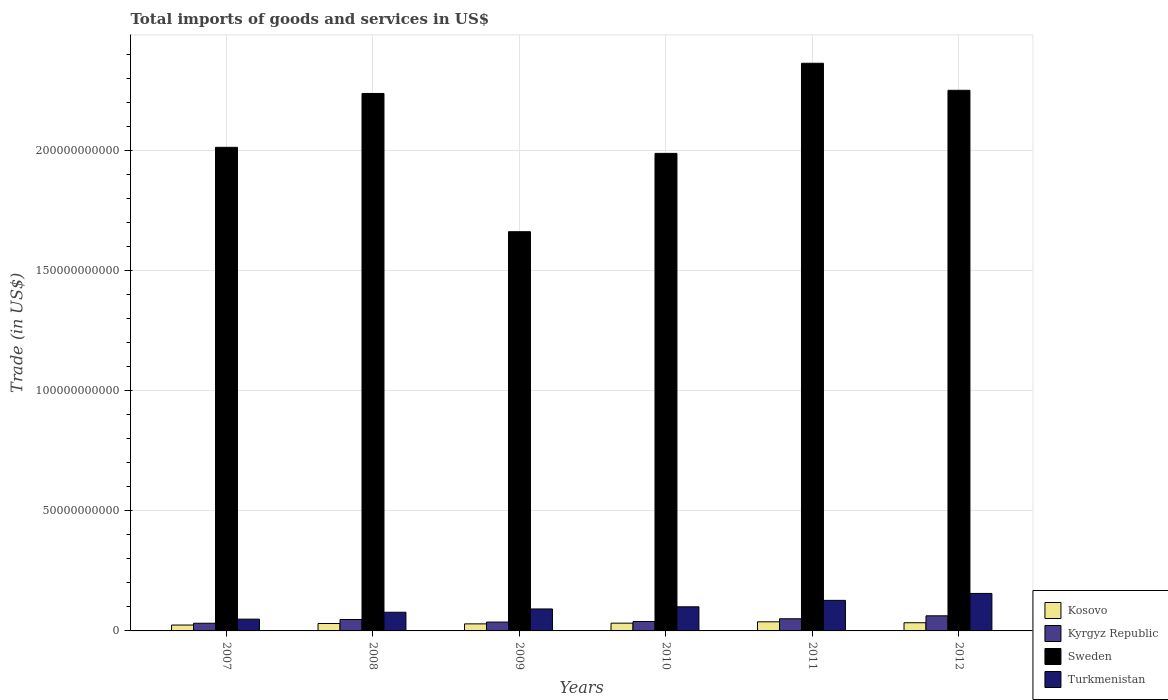How many different coloured bars are there?
Ensure brevity in your answer.  4. Are the number of bars per tick equal to the number of legend labels?
Offer a terse response. Yes. Are the number of bars on each tick of the X-axis equal?
Your response must be concise. Yes. How many bars are there on the 4th tick from the left?
Give a very brief answer. 4. How many bars are there on the 6th tick from the right?
Provide a short and direct response. 4. What is the label of the 6th group of bars from the left?
Your response must be concise. 2012. What is the total imports of goods and services in Kosovo in 2011?
Your answer should be compact. 3.80e+09. Across all years, what is the maximum total imports of goods and services in Sweden?
Make the answer very short. 2.36e+11. Across all years, what is the minimum total imports of goods and services in Kosovo?
Offer a terse response. 2.45e+09. In which year was the total imports of goods and services in Sweden minimum?
Give a very brief answer. 2009. What is the total total imports of goods and services in Sweden in the graph?
Your answer should be very brief. 1.25e+12. What is the difference between the total imports of goods and services in Kyrgyz Republic in 2010 and that in 2012?
Give a very brief answer. -2.38e+09. What is the difference between the total imports of goods and services in Kosovo in 2008 and the total imports of goods and services in Turkmenistan in 2010?
Give a very brief answer. -6.96e+09. What is the average total imports of goods and services in Sweden per year?
Your response must be concise. 2.09e+11. In the year 2012, what is the difference between the total imports of goods and services in Kosovo and total imports of goods and services in Kyrgyz Republic?
Make the answer very short. -2.89e+09. In how many years, is the total imports of goods and services in Turkmenistan greater than 140000000000 US$?
Make the answer very short. 0. What is the ratio of the total imports of goods and services in Kyrgyz Republic in 2007 to that in 2009?
Give a very brief answer. 0.87. Is the total imports of goods and services in Kyrgyz Republic in 2008 less than that in 2009?
Offer a very short reply. No. Is the difference between the total imports of goods and services in Kosovo in 2007 and 2010 greater than the difference between the total imports of goods and services in Kyrgyz Republic in 2007 and 2010?
Your response must be concise. No. What is the difference between the highest and the second highest total imports of goods and services in Sweden?
Your answer should be compact. 1.13e+1. What is the difference between the highest and the lowest total imports of goods and services in Sweden?
Keep it short and to the point. 7.01e+1. In how many years, is the total imports of goods and services in Sweden greater than the average total imports of goods and services in Sweden taken over all years?
Provide a short and direct response. 3. What does the 1st bar from the left in 2011 represents?
Offer a terse response. Kosovo. Is it the case that in every year, the sum of the total imports of goods and services in Kyrgyz Republic and total imports of goods and services in Turkmenistan is greater than the total imports of goods and services in Sweden?
Your response must be concise. No. How many bars are there?
Your answer should be compact. 24. Are all the bars in the graph horizontal?
Provide a succinct answer. No. What is the difference between two consecutive major ticks on the Y-axis?
Give a very brief answer. 5.00e+1. Does the graph contain any zero values?
Ensure brevity in your answer.  No. How are the legend labels stacked?
Your answer should be compact. Vertical. What is the title of the graph?
Offer a terse response. Total imports of goods and services in US$. Does "Cuba" appear as one of the legend labels in the graph?
Your answer should be very brief. No. What is the label or title of the X-axis?
Ensure brevity in your answer.  Years. What is the label or title of the Y-axis?
Your answer should be very brief. Trade (in US$). What is the Trade (in US$) of Kosovo in 2007?
Offer a terse response. 2.45e+09. What is the Trade (in US$) of Kyrgyz Republic in 2007?
Your response must be concise. 3.20e+09. What is the Trade (in US$) in Sweden in 2007?
Your answer should be compact. 2.01e+11. What is the Trade (in US$) in Turkmenistan in 2007?
Your answer should be compact. 4.90e+09. What is the Trade (in US$) in Kosovo in 2008?
Your answer should be compact. 3.09e+09. What is the Trade (in US$) of Kyrgyz Republic in 2008?
Make the answer very short. 4.76e+09. What is the Trade (in US$) in Sweden in 2008?
Provide a succinct answer. 2.24e+11. What is the Trade (in US$) in Turkmenistan in 2008?
Provide a short and direct response. 7.78e+09. What is the Trade (in US$) of Kosovo in 2009?
Your response must be concise. 2.94e+09. What is the Trade (in US$) in Kyrgyz Republic in 2009?
Provide a succinct answer. 3.69e+09. What is the Trade (in US$) of Sweden in 2009?
Provide a succinct answer. 1.66e+11. What is the Trade (in US$) in Turkmenistan in 2009?
Give a very brief answer. 9.14e+09. What is the Trade (in US$) in Kosovo in 2010?
Keep it short and to the point. 3.23e+09. What is the Trade (in US$) in Kyrgyz Republic in 2010?
Provide a succinct answer. 3.92e+09. What is the Trade (in US$) in Sweden in 2010?
Your response must be concise. 1.99e+11. What is the Trade (in US$) in Turkmenistan in 2010?
Your response must be concise. 1.00e+1. What is the Trade (in US$) of Kosovo in 2011?
Provide a succinct answer. 3.80e+09. What is the Trade (in US$) of Kyrgyz Republic in 2011?
Ensure brevity in your answer.  5.06e+09. What is the Trade (in US$) of Sweden in 2011?
Give a very brief answer. 2.36e+11. What is the Trade (in US$) in Turkmenistan in 2011?
Keep it short and to the point. 1.27e+1. What is the Trade (in US$) of Kosovo in 2012?
Make the answer very short. 3.40e+09. What is the Trade (in US$) in Kyrgyz Republic in 2012?
Provide a succinct answer. 6.29e+09. What is the Trade (in US$) in Sweden in 2012?
Make the answer very short. 2.25e+11. What is the Trade (in US$) in Turkmenistan in 2012?
Make the answer very short. 1.56e+1. Across all years, what is the maximum Trade (in US$) of Kosovo?
Ensure brevity in your answer.  3.80e+09. Across all years, what is the maximum Trade (in US$) of Kyrgyz Republic?
Provide a succinct answer. 6.29e+09. Across all years, what is the maximum Trade (in US$) of Sweden?
Your answer should be very brief. 2.36e+11. Across all years, what is the maximum Trade (in US$) in Turkmenistan?
Your response must be concise. 1.56e+1. Across all years, what is the minimum Trade (in US$) in Kosovo?
Ensure brevity in your answer.  2.45e+09. Across all years, what is the minimum Trade (in US$) of Kyrgyz Republic?
Provide a succinct answer. 3.20e+09. Across all years, what is the minimum Trade (in US$) in Sweden?
Offer a terse response. 1.66e+11. Across all years, what is the minimum Trade (in US$) in Turkmenistan?
Your answer should be very brief. 4.90e+09. What is the total Trade (in US$) in Kosovo in the graph?
Your response must be concise. 1.89e+1. What is the total Trade (in US$) of Kyrgyz Republic in the graph?
Offer a very short reply. 2.69e+1. What is the total Trade (in US$) in Sweden in the graph?
Provide a short and direct response. 1.25e+12. What is the total Trade (in US$) in Turkmenistan in the graph?
Your answer should be very brief. 6.02e+1. What is the difference between the Trade (in US$) of Kosovo in 2007 and that in 2008?
Ensure brevity in your answer.  -6.37e+08. What is the difference between the Trade (in US$) in Kyrgyz Republic in 2007 and that in 2008?
Provide a short and direct response. -1.56e+09. What is the difference between the Trade (in US$) in Sweden in 2007 and that in 2008?
Offer a terse response. -2.24e+1. What is the difference between the Trade (in US$) in Turkmenistan in 2007 and that in 2008?
Provide a short and direct response. -2.88e+09. What is the difference between the Trade (in US$) in Kosovo in 2007 and that in 2009?
Ensure brevity in your answer.  -4.88e+08. What is the difference between the Trade (in US$) of Kyrgyz Republic in 2007 and that in 2009?
Give a very brief answer. -4.90e+08. What is the difference between the Trade (in US$) in Sweden in 2007 and that in 2009?
Your answer should be very brief. 3.51e+1. What is the difference between the Trade (in US$) in Turkmenistan in 2007 and that in 2009?
Your answer should be compact. -4.24e+09. What is the difference between the Trade (in US$) in Kosovo in 2007 and that in 2010?
Offer a terse response. -7.82e+08. What is the difference between the Trade (in US$) in Kyrgyz Republic in 2007 and that in 2010?
Give a very brief answer. -7.16e+08. What is the difference between the Trade (in US$) in Sweden in 2007 and that in 2010?
Provide a short and direct response. 2.52e+09. What is the difference between the Trade (in US$) of Turkmenistan in 2007 and that in 2010?
Your response must be concise. -5.14e+09. What is the difference between the Trade (in US$) in Kosovo in 2007 and that in 2011?
Keep it short and to the point. -1.35e+09. What is the difference between the Trade (in US$) of Kyrgyz Republic in 2007 and that in 2011?
Your answer should be very brief. -1.86e+09. What is the difference between the Trade (in US$) in Sweden in 2007 and that in 2011?
Keep it short and to the point. -3.50e+1. What is the difference between the Trade (in US$) in Turkmenistan in 2007 and that in 2011?
Make the answer very short. -7.82e+09. What is the difference between the Trade (in US$) of Kosovo in 2007 and that in 2012?
Provide a succinct answer. -9.56e+08. What is the difference between the Trade (in US$) of Kyrgyz Republic in 2007 and that in 2012?
Keep it short and to the point. -3.09e+09. What is the difference between the Trade (in US$) of Sweden in 2007 and that in 2012?
Ensure brevity in your answer.  -2.37e+1. What is the difference between the Trade (in US$) of Turkmenistan in 2007 and that in 2012?
Your response must be concise. -1.07e+1. What is the difference between the Trade (in US$) of Kosovo in 2008 and that in 2009?
Your answer should be very brief. 1.49e+08. What is the difference between the Trade (in US$) of Kyrgyz Republic in 2008 and that in 2009?
Ensure brevity in your answer.  1.07e+09. What is the difference between the Trade (in US$) of Sweden in 2008 and that in 2009?
Make the answer very short. 5.76e+1. What is the difference between the Trade (in US$) in Turkmenistan in 2008 and that in 2009?
Offer a terse response. -1.36e+09. What is the difference between the Trade (in US$) in Kosovo in 2008 and that in 2010?
Provide a succinct answer. -1.45e+08. What is the difference between the Trade (in US$) in Kyrgyz Republic in 2008 and that in 2010?
Ensure brevity in your answer.  8.41e+08. What is the difference between the Trade (in US$) of Sweden in 2008 and that in 2010?
Keep it short and to the point. 2.50e+1. What is the difference between the Trade (in US$) of Turkmenistan in 2008 and that in 2010?
Your answer should be very brief. -2.26e+09. What is the difference between the Trade (in US$) of Kosovo in 2008 and that in 2011?
Offer a very short reply. -7.13e+08. What is the difference between the Trade (in US$) in Kyrgyz Republic in 2008 and that in 2011?
Offer a terse response. -3.03e+08. What is the difference between the Trade (in US$) in Sweden in 2008 and that in 2011?
Keep it short and to the point. -1.26e+1. What is the difference between the Trade (in US$) in Turkmenistan in 2008 and that in 2011?
Keep it short and to the point. -4.94e+09. What is the difference between the Trade (in US$) of Kosovo in 2008 and that in 2012?
Ensure brevity in your answer.  -3.19e+08. What is the difference between the Trade (in US$) of Kyrgyz Republic in 2008 and that in 2012?
Give a very brief answer. -1.54e+09. What is the difference between the Trade (in US$) in Sweden in 2008 and that in 2012?
Give a very brief answer. -1.31e+09. What is the difference between the Trade (in US$) of Turkmenistan in 2008 and that in 2012?
Offer a terse response. -7.83e+09. What is the difference between the Trade (in US$) in Kosovo in 2009 and that in 2010?
Your answer should be very brief. -2.94e+08. What is the difference between the Trade (in US$) in Kyrgyz Republic in 2009 and that in 2010?
Your answer should be very brief. -2.26e+08. What is the difference between the Trade (in US$) of Sweden in 2009 and that in 2010?
Provide a short and direct response. -3.26e+1. What is the difference between the Trade (in US$) in Turkmenistan in 2009 and that in 2010?
Your answer should be very brief. -8.99e+08. What is the difference between the Trade (in US$) in Kosovo in 2009 and that in 2011?
Offer a terse response. -8.62e+08. What is the difference between the Trade (in US$) in Kyrgyz Republic in 2009 and that in 2011?
Your answer should be compact. -1.37e+09. What is the difference between the Trade (in US$) of Sweden in 2009 and that in 2011?
Give a very brief answer. -7.01e+1. What is the difference between the Trade (in US$) in Turkmenistan in 2009 and that in 2011?
Offer a very short reply. -3.58e+09. What is the difference between the Trade (in US$) in Kosovo in 2009 and that in 2012?
Your answer should be compact. -4.68e+08. What is the difference between the Trade (in US$) of Kyrgyz Republic in 2009 and that in 2012?
Provide a succinct answer. -2.60e+09. What is the difference between the Trade (in US$) in Sweden in 2009 and that in 2012?
Offer a very short reply. -5.89e+1. What is the difference between the Trade (in US$) in Turkmenistan in 2009 and that in 2012?
Your response must be concise. -6.47e+09. What is the difference between the Trade (in US$) of Kosovo in 2010 and that in 2011?
Your response must be concise. -5.68e+08. What is the difference between the Trade (in US$) of Kyrgyz Republic in 2010 and that in 2011?
Your answer should be very brief. -1.14e+09. What is the difference between the Trade (in US$) in Sweden in 2010 and that in 2011?
Make the answer very short. -3.75e+1. What is the difference between the Trade (in US$) in Turkmenistan in 2010 and that in 2011?
Give a very brief answer. -2.68e+09. What is the difference between the Trade (in US$) of Kosovo in 2010 and that in 2012?
Provide a succinct answer. -1.74e+08. What is the difference between the Trade (in US$) in Kyrgyz Republic in 2010 and that in 2012?
Offer a very short reply. -2.38e+09. What is the difference between the Trade (in US$) in Sweden in 2010 and that in 2012?
Offer a very short reply. -2.63e+1. What is the difference between the Trade (in US$) of Turkmenistan in 2010 and that in 2012?
Your response must be concise. -5.57e+09. What is the difference between the Trade (in US$) in Kosovo in 2011 and that in 2012?
Provide a short and direct response. 3.94e+08. What is the difference between the Trade (in US$) of Kyrgyz Republic in 2011 and that in 2012?
Provide a short and direct response. -1.23e+09. What is the difference between the Trade (in US$) in Sweden in 2011 and that in 2012?
Ensure brevity in your answer.  1.13e+1. What is the difference between the Trade (in US$) of Turkmenistan in 2011 and that in 2012?
Provide a short and direct response. -2.88e+09. What is the difference between the Trade (in US$) of Kosovo in 2007 and the Trade (in US$) of Kyrgyz Republic in 2008?
Your response must be concise. -2.31e+09. What is the difference between the Trade (in US$) in Kosovo in 2007 and the Trade (in US$) in Sweden in 2008?
Offer a terse response. -2.21e+11. What is the difference between the Trade (in US$) in Kosovo in 2007 and the Trade (in US$) in Turkmenistan in 2008?
Keep it short and to the point. -5.33e+09. What is the difference between the Trade (in US$) of Kyrgyz Republic in 2007 and the Trade (in US$) of Sweden in 2008?
Provide a succinct answer. -2.21e+11. What is the difference between the Trade (in US$) of Kyrgyz Republic in 2007 and the Trade (in US$) of Turkmenistan in 2008?
Offer a terse response. -4.58e+09. What is the difference between the Trade (in US$) of Sweden in 2007 and the Trade (in US$) of Turkmenistan in 2008?
Offer a very short reply. 1.94e+11. What is the difference between the Trade (in US$) in Kosovo in 2007 and the Trade (in US$) in Kyrgyz Republic in 2009?
Ensure brevity in your answer.  -1.24e+09. What is the difference between the Trade (in US$) of Kosovo in 2007 and the Trade (in US$) of Sweden in 2009?
Offer a very short reply. -1.64e+11. What is the difference between the Trade (in US$) in Kosovo in 2007 and the Trade (in US$) in Turkmenistan in 2009?
Your answer should be compact. -6.70e+09. What is the difference between the Trade (in US$) of Kyrgyz Republic in 2007 and the Trade (in US$) of Sweden in 2009?
Keep it short and to the point. -1.63e+11. What is the difference between the Trade (in US$) of Kyrgyz Republic in 2007 and the Trade (in US$) of Turkmenistan in 2009?
Your response must be concise. -5.95e+09. What is the difference between the Trade (in US$) of Sweden in 2007 and the Trade (in US$) of Turkmenistan in 2009?
Give a very brief answer. 1.92e+11. What is the difference between the Trade (in US$) of Kosovo in 2007 and the Trade (in US$) of Kyrgyz Republic in 2010?
Give a very brief answer. -1.47e+09. What is the difference between the Trade (in US$) of Kosovo in 2007 and the Trade (in US$) of Sweden in 2010?
Your answer should be compact. -1.96e+11. What is the difference between the Trade (in US$) in Kosovo in 2007 and the Trade (in US$) in Turkmenistan in 2010?
Offer a very short reply. -7.60e+09. What is the difference between the Trade (in US$) of Kyrgyz Republic in 2007 and the Trade (in US$) of Sweden in 2010?
Provide a succinct answer. -1.96e+11. What is the difference between the Trade (in US$) of Kyrgyz Republic in 2007 and the Trade (in US$) of Turkmenistan in 2010?
Give a very brief answer. -6.84e+09. What is the difference between the Trade (in US$) in Sweden in 2007 and the Trade (in US$) in Turkmenistan in 2010?
Give a very brief answer. 1.91e+11. What is the difference between the Trade (in US$) in Kosovo in 2007 and the Trade (in US$) in Kyrgyz Republic in 2011?
Offer a terse response. -2.61e+09. What is the difference between the Trade (in US$) of Kosovo in 2007 and the Trade (in US$) of Sweden in 2011?
Provide a succinct answer. -2.34e+11. What is the difference between the Trade (in US$) of Kosovo in 2007 and the Trade (in US$) of Turkmenistan in 2011?
Make the answer very short. -1.03e+1. What is the difference between the Trade (in US$) in Kyrgyz Republic in 2007 and the Trade (in US$) in Sweden in 2011?
Your answer should be very brief. -2.33e+11. What is the difference between the Trade (in US$) of Kyrgyz Republic in 2007 and the Trade (in US$) of Turkmenistan in 2011?
Offer a very short reply. -9.53e+09. What is the difference between the Trade (in US$) in Sweden in 2007 and the Trade (in US$) in Turkmenistan in 2011?
Provide a short and direct response. 1.89e+11. What is the difference between the Trade (in US$) of Kosovo in 2007 and the Trade (in US$) of Kyrgyz Republic in 2012?
Give a very brief answer. -3.84e+09. What is the difference between the Trade (in US$) in Kosovo in 2007 and the Trade (in US$) in Sweden in 2012?
Your answer should be very brief. -2.23e+11. What is the difference between the Trade (in US$) in Kosovo in 2007 and the Trade (in US$) in Turkmenistan in 2012?
Offer a very short reply. -1.32e+1. What is the difference between the Trade (in US$) in Kyrgyz Republic in 2007 and the Trade (in US$) in Sweden in 2012?
Your answer should be compact. -2.22e+11. What is the difference between the Trade (in US$) of Kyrgyz Republic in 2007 and the Trade (in US$) of Turkmenistan in 2012?
Provide a short and direct response. -1.24e+1. What is the difference between the Trade (in US$) in Sweden in 2007 and the Trade (in US$) in Turkmenistan in 2012?
Provide a short and direct response. 1.86e+11. What is the difference between the Trade (in US$) of Kosovo in 2008 and the Trade (in US$) of Kyrgyz Republic in 2009?
Provide a short and direct response. -6.05e+08. What is the difference between the Trade (in US$) in Kosovo in 2008 and the Trade (in US$) in Sweden in 2009?
Keep it short and to the point. -1.63e+11. What is the difference between the Trade (in US$) of Kosovo in 2008 and the Trade (in US$) of Turkmenistan in 2009?
Ensure brevity in your answer.  -6.06e+09. What is the difference between the Trade (in US$) of Kyrgyz Republic in 2008 and the Trade (in US$) of Sweden in 2009?
Offer a terse response. -1.61e+11. What is the difference between the Trade (in US$) of Kyrgyz Republic in 2008 and the Trade (in US$) of Turkmenistan in 2009?
Ensure brevity in your answer.  -4.39e+09. What is the difference between the Trade (in US$) of Sweden in 2008 and the Trade (in US$) of Turkmenistan in 2009?
Keep it short and to the point. 2.15e+11. What is the difference between the Trade (in US$) in Kosovo in 2008 and the Trade (in US$) in Kyrgyz Republic in 2010?
Ensure brevity in your answer.  -8.31e+08. What is the difference between the Trade (in US$) of Kosovo in 2008 and the Trade (in US$) of Sweden in 2010?
Provide a short and direct response. -1.96e+11. What is the difference between the Trade (in US$) in Kosovo in 2008 and the Trade (in US$) in Turkmenistan in 2010?
Provide a short and direct response. -6.96e+09. What is the difference between the Trade (in US$) in Kyrgyz Republic in 2008 and the Trade (in US$) in Sweden in 2010?
Your answer should be compact. -1.94e+11. What is the difference between the Trade (in US$) of Kyrgyz Republic in 2008 and the Trade (in US$) of Turkmenistan in 2010?
Offer a very short reply. -5.29e+09. What is the difference between the Trade (in US$) of Sweden in 2008 and the Trade (in US$) of Turkmenistan in 2010?
Provide a short and direct response. 2.14e+11. What is the difference between the Trade (in US$) in Kosovo in 2008 and the Trade (in US$) in Kyrgyz Republic in 2011?
Ensure brevity in your answer.  -1.97e+09. What is the difference between the Trade (in US$) in Kosovo in 2008 and the Trade (in US$) in Sweden in 2011?
Offer a terse response. -2.33e+11. What is the difference between the Trade (in US$) in Kosovo in 2008 and the Trade (in US$) in Turkmenistan in 2011?
Give a very brief answer. -9.64e+09. What is the difference between the Trade (in US$) of Kyrgyz Republic in 2008 and the Trade (in US$) of Sweden in 2011?
Keep it short and to the point. -2.32e+11. What is the difference between the Trade (in US$) in Kyrgyz Republic in 2008 and the Trade (in US$) in Turkmenistan in 2011?
Your answer should be compact. -7.97e+09. What is the difference between the Trade (in US$) of Sweden in 2008 and the Trade (in US$) of Turkmenistan in 2011?
Give a very brief answer. 2.11e+11. What is the difference between the Trade (in US$) in Kosovo in 2008 and the Trade (in US$) in Kyrgyz Republic in 2012?
Make the answer very short. -3.21e+09. What is the difference between the Trade (in US$) of Kosovo in 2008 and the Trade (in US$) of Sweden in 2012?
Provide a succinct answer. -2.22e+11. What is the difference between the Trade (in US$) of Kosovo in 2008 and the Trade (in US$) of Turkmenistan in 2012?
Your answer should be compact. -1.25e+1. What is the difference between the Trade (in US$) of Kyrgyz Republic in 2008 and the Trade (in US$) of Sweden in 2012?
Your answer should be very brief. -2.20e+11. What is the difference between the Trade (in US$) in Kyrgyz Republic in 2008 and the Trade (in US$) in Turkmenistan in 2012?
Provide a succinct answer. -1.09e+1. What is the difference between the Trade (in US$) of Sweden in 2008 and the Trade (in US$) of Turkmenistan in 2012?
Keep it short and to the point. 2.08e+11. What is the difference between the Trade (in US$) of Kosovo in 2009 and the Trade (in US$) of Kyrgyz Republic in 2010?
Your answer should be compact. -9.80e+08. What is the difference between the Trade (in US$) in Kosovo in 2009 and the Trade (in US$) in Sweden in 2010?
Make the answer very short. -1.96e+11. What is the difference between the Trade (in US$) in Kosovo in 2009 and the Trade (in US$) in Turkmenistan in 2010?
Offer a terse response. -7.11e+09. What is the difference between the Trade (in US$) in Kyrgyz Republic in 2009 and the Trade (in US$) in Sweden in 2010?
Provide a short and direct response. -1.95e+11. What is the difference between the Trade (in US$) in Kyrgyz Republic in 2009 and the Trade (in US$) in Turkmenistan in 2010?
Ensure brevity in your answer.  -6.35e+09. What is the difference between the Trade (in US$) of Sweden in 2009 and the Trade (in US$) of Turkmenistan in 2010?
Your response must be concise. 1.56e+11. What is the difference between the Trade (in US$) in Kosovo in 2009 and the Trade (in US$) in Kyrgyz Republic in 2011?
Give a very brief answer. -2.12e+09. What is the difference between the Trade (in US$) of Kosovo in 2009 and the Trade (in US$) of Sweden in 2011?
Offer a very short reply. -2.33e+11. What is the difference between the Trade (in US$) of Kosovo in 2009 and the Trade (in US$) of Turkmenistan in 2011?
Your answer should be very brief. -9.79e+09. What is the difference between the Trade (in US$) of Kyrgyz Republic in 2009 and the Trade (in US$) of Sweden in 2011?
Give a very brief answer. -2.33e+11. What is the difference between the Trade (in US$) in Kyrgyz Republic in 2009 and the Trade (in US$) in Turkmenistan in 2011?
Your answer should be compact. -9.04e+09. What is the difference between the Trade (in US$) of Sweden in 2009 and the Trade (in US$) of Turkmenistan in 2011?
Ensure brevity in your answer.  1.54e+11. What is the difference between the Trade (in US$) of Kosovo in 2009 and the Trade (in US$) of Kyrgyz Republic in 2012?
Your answer should be very brief. -3.36e+09. What is the difference between the Trade (in US$) in Kosovo in 2009 and the Trade (in US$) in Sweden in 2012?
Provide a succinct answer. -2.22e+11. What is the difference between the Trade (in US$) in Kosovo in 2009 and the Trade (in US$) in Turkmenistan in 2012?
Your answer should be compact. -1.27e+1. What is the difference between the Trade (in US$) of Kyrgyz Republic in 2009 and the Trade (in US$) of Sweden in 2012?
Your answer should be compact. -2.21e+11. What is the difference between the Trade (in US$) in Kyrgyz Republic in 2009 and the Trade (in US$) in Turkmenistan in 2012?
Provide a short and direct response. -1.19e+1. What is the difference between the Trade (in US$) in Sweden in 2009 and the Trade (in US$) in Turkmenistan in 2012?
Keep it short and to the point. 1.51e+11. What is the difference between the Trade (in US$) of Kosovo in 2010 and the Trade (in US$) of Kyrgyz Republic in 2011?
Provide a short and direct response. -1.83e+09. What is the difference between the Trade (in US$) in Kosovo in 2010 and the Trade (in US$) in Sweden in 2011?
Your answer should be very brief. -2.33e+11. What is the difference between the Trade (in US$) in Kosovo in 2010 and the Trade (in US$) in Turkmenistan in 2011?
Offer a very short reply. -9.49e+09. What is the difference between the Trade (in US$) in Kyrgyz Republic in 2010 and the Trade (in US$) in Sweden in 2011?
Provide a succinct answer. -2.32e+11. What is the difference between the Trade (in US$) in Kyrgyz Republic in 2010 and the Trade (in US$) in Turkmenistan in 2011?
Keep it short and to the point. -8.81e+09. What is the difference between the Trade (in US$) in Sweden in 2010 and the Trade (in US$) in Turkmenistan in 2011?
Offer a terse response. 1.86e+11. What is the difference between the Trade (in US$) of Kosovo in 2010 and the Trade (in US$) of Kyrgyz Republic in 2012?
Give a very brief answer. -3.06e+09. What is the difference between the Trade (in US$) in Kosovo in 2010 and the Trade (in US$) in Sweden in 2012?
Provide a short and direct response. -2.22e+11. What is the difference between the Trade (in US$) in Kosovo in 2010 and the Trade (in US$) in Turkmenistan in 2012?
Provide a short and direct response. -1.24e+1. What is the difference between the Trade (in US$) in Kyrgyz Republic in 2010 and the Trade (in US$) in Sweden in 2012?
Offer a very short reply. -2.21e+11. What is the difference between the Trade (in US$) in Kyrgyz Republic in 2010 and the Trade (in US$) in Turkmenistan in 2012?
Offer a very short reply. -1.17e+1. What is the difference between the Trade (in US$) in Sweden in 2010 and the Trade (in US$) in Turkmenistan in 2012?
Your answer should be very brief. 1.83e+11. What is the difference between the Trade (in US$) in Kosovo in 2011 and the Trade (in US$) in Kyrgyz Republic in 2012?
Keep it short and to the point. -2.49e+09. What is the difference between the Trade (in US$) in Kosovo in 2011 and the Trade (in US$) in Sweden in 2012?
Offer a very short reply. -2.21e+11. What is the difference between the Trade (in US$) in Kosovo in 2011 and the Trade (in US$) in Turkmenistan in 2012?
Give a very brief answer. -1.18e+1. What is the difference between the Trade (in US$) of Kyrgyz Republic in 2011 and the Trade (in US$) of Sweden in 2012?
Give a very brief answer. -2.20e+11. What is the difference between the Trade (in US$) of Kyrgyz Republic in 2011 and the Trade (in US$) of Turkmenistan in 2012?
Your answer should be compact. -1.06e+1. What is the difference between the Trade (in US$) in Sweden in 2011 and the Trade (in US$) in Turkmenistan in 2012?
Make the answer very short. 2.21e+11. What is the average Trade (in US$) of Kosovo per year?
Provide a succinct answer. 3.15e+09. What is the average Trade (in US$) of Kyrgyz Republic per year?
Keep it short and to the point. 4.49e+09. What is the average Trade (in US$) of Sweden per year?
Give a very brief answer. 2.09e+11. What is the average Trade (in US$) of Turkmenistan per year?
Your answer should be very brief. 1.00e+1. In the year 2007, what is the difference between the Trade (in US$) in Kosovo and Trade (in US$) in Kyrgyz Republic?
Offer a terse response. -7.51e+08. In the year 2007, what is the difference between the Trade (in US$) of Kosovo and Trade (in US$) of Sweden?
Your response must be concise. -1.99e+11. In the year 2007, what is the difference between the Trade (in US$) in Kosovo and Trade (in US$) in Turkmenistan?
Provide a succinct answer. -2.45e+09. In the year 2007, what is the difference between the Trade (in US$) in Kyrgyz Republic and Trade (in US$) in Sweden?
Ensure brevity in your answer.  -1.98e+11. In the year 2007, what is the difference between the Trade (in US$) of Kyrgyz Republic and Trade (in US$) of Turkmenistan?
Keep it short and to the point. -1.70e+09. In the year 2007, what is the difference between the Trade (in US$) in Sweden and Trade (in US$) in Turkmenistan?
Your answer should be compact. 1.96e+11. In the year 2008, what is the difference between the Trade (in US$) in Kosovo and Trade (in US$) in Kyrgyz Republic?
Provide a succinct answer. -1.67e+09. In the year 2008, what is the difference between the Trade (in US$) of Kosovo and Trade (in US$) of Sweden?
Your response must be concise. -2.21e+11. In the year 2008, what is the difference between the Trade (in US$) in Kosovo and Trade (in US$) in Turkmenistan?
Your answer should be compact. -4.70e+09. In the year 2008, what is the difference between the Trade (in US$) of Kyrgyz Republic and Trade (in US$) of Sweden?
Provide a succinct answer. -2.19e+11. In the year 2008, what is the difference between the Trade (in US$) of Kyrgyz Republic and Trade (in US$) of Turkmenistan?
Keep it short and to the point. -3.02e+09. In the year 2008, what is the difference between the Trade (in US$) in Sweden and Trade (in US$) in Turkmenistan?
Your response must be concise. 2.16e+11. In the year 2009, what is the difference between the Trade (in US$) of Kosovo and Trade (in US$) of Kyrgyz Republic?
Your answer should be very brief. -7.54e+08. In the year 2009, what is the difference between the Trade (in US$) of Kosovo and Trade (in US$) of Sweden?
Offer a terse response. -1.63e+11. In the year 2009, what is the difference between the Trade (in US$) in Kosovo and Trade (in US$) in Turkmenistan?
Your answer should be compact. -6.21e+09. In the year 2009, what is the difference between the Trade (in US$) in Kyrgyz Republic and Trade (in US$) in Sweden?
Offer a very short reply. -1.63e+11. In the year 2009, what is the difference between the Trade (in US$) of Kyrgyz Republic and Trade (in US$) of Turkmenistan?
Provide a short and direct response. -5.45e+09. In the year 2009, what is the difference between the Trade (in US$) of Sweden and Trade (in US$) of Turkmenistan?
Provide a short and direct response. 1.57e+11. In the year 2010, what is the difference between the Trade (in US$) of Kosovo and Trade (in US$) of Kyrgyz Republic?
Make the answer very short. -6.85e+08. In the year 2010, what is the difference between the Trade (in US$) of Kosovo and Trade (in US$) of Sweden?
Your response must be concise. -1.96e+11. In the year 2010, what is the difference between the Trade (in US$) of Kosovo and Trade (in US$) of Turkmenistan?
Offer a terse response. -6.81e+09. In the year 2010, what is the difference between the Trade (in US$) in Kyrgyz Republic and Trade (in US$) in Sweden?
Provide a succinct answer. -1.95e+11. In the year 2010, what is the difference between the Trade (in US$) in Kyrgyz Republic and Trade (in US$) in Turkmenistan?
Offer a terse response. -6.13e+09. In the year 2010, what is the difference between the Trade (in US$) in Sweden and Trade (in US$) in Turkmenistan?
Provide a succinct answer. 1.89e+11. In the year 2011, what is the difference between the Trade (in US$) of Kosovo and Trade (in US$) of Kyrgyz Republic?
Your answer should be compact. -1.26e+09. In the year 2011, what is the difference between the Trade (in US$) of Kosovo and Trade (in US$) of Sweden?
Your response must be concise. -2.33e+11. In the year 2011, what is the difference between the Trade (in US$) in Kosovo and Trade (in US$) in Turkmenistan?
Make the answer very short. -8.93e+09. In the year 2011, what is the difference between the Trade (in US$) in Kyrgyz Republic and Trade (in US$) in Sweden?
Your answer should be very brief. -2.31e+11. In the year 2011, what is the difference between the Trade (in US$) of Kyrgyz Republic and Trade (in US$) of Turkmenistan?
Provide a succinct answer. -7.67e+09. In the year 2011, what is the difference between the Trade (in US$) in Sweden and Trade (in US$) in Turkmenistan?
Your answer should be very brief. 2.24e+11. In the year 2012, what is the difference between the Trade (in US$) in Kosovo and Trade (in US$) in Kyrgyz Republic?
Provide a short and direct response. -2.89e+09. In the year 2012, what is the difference between the Trade (in US$) of Kosovo and Trade (in US$) of Sweden?
Your response must be concise. -2.22e+11. In the year 2012, what is the difference between the Trade (in US$) in Kosovo and Trade (in US$) in Turkmenistan?
Offer a very short reply. -1.22e+1. In the year 2012, what is the difference between the Trade (in US$) of Kyrgyz Republic and Trade (in US$) of Sweden?
Your response must be concise. -2.19e+11. In the year 2012, what is the difference between the Trade (in US$) in Kyrgyz Republic and Trade (in US$) in Turkmenistan?
Ensure brevity in your answer.  -9.32e+09. In the year 2012, what is the difference between the Trade (in US$) of Sweden and Trade (in US$) of Turkmenistan?
Give a very brief answer. 2.10e+11. What is the ratio of the Trade (in US$) of Kosovo in 2007 to that in 2008?
Provide a succinct answer. 0.79. What is the ratio of the Trade (in US$) in Kyrgyz Republic in 2007 to that in 2008?
Offer a very short reply. 0.67. What is the ratio of the Trade (in US$) of Sweden in 2007 to that in 2008?
Your answer should be very brief. 0.9. What is the ratio of the Trade (in US$) in Turkmenistan in 2007 to that in 2008?
Ensure brevity in your answer.  0.63. What is the ratio of the Trade (in US$) of Kosovo in 2007 to that in 2009?
Your response must be concise. 0.83. What is the ratio of the Trade (in US$) in Kyrgyz Republic in 2007 to that in 2009?
Ensure brevity in your answer.  0.87. What is the ratio of the Trade (in US$) of Sweden in 2007 to that in 2009?
Ensure brevity in your answer.  1.21. What is the ratio of the Trade (in US$) of Turkmenistan in 2007 to that in 2009?
Your answer should be compact. 0.54. What is the ratio of the Trade (in US$) in Kosovo in 2007 to that in 2010?
Offer a terse response. 0.76. What is the ratio of the Trade (in US$) in Kyrgyz Republic in 2007 to that in 2010?
Ensure brevity in your answer.  0.82. What is the ratio of the Trade (in US$) of Sweden in 2007 to that in 2010?
Ensure brevity in your answer.  1.01. What is the ratio of the Trade (in US$) in Turkmenistan in 2007 to that in 2010?
Provide a succinct answer. 0.49. What is the ratio of the Trade (in US$) of Kosovo in 2007 to that in 2011?
Keep it short and to the point. 0.64. What is the ratio of the Trade (in US$) of Kyrgyz Republic in 2007 to that in 2011?
Ensure brevity in your answer.  0.63. What is the ratio of the Trade (in US$) in Sweden in 2007 to that in 2011?
Make the answer very short. 0.85. What is the ratio of the Trade (in US$) in Turkmenistan in 2007 to that in 2011?
Provide a short and direct response. 0.39. What is the ratio of the Trade (in US$) of Kosovo in 2007 to that in 2012?
Your response must be concise. 0.72. What is the ratio of the Trade (in US$) of Kyrgyz Republic in 2007 to that in 2012?
Keep it short and to the point. 0.51. What is the ratio of the Trade (in US$) in Sweden in 2007 to that in 2012?
Offer a very short reply. 0.89. What is the ratio of the Trade (in US$) in Turkmenistan in 2007 to that in 2012?
Give a very brief answer. 0.31. What is the ratio of the Trade (in US$) in Kosovo in 2008 to that in 2009?
Your response must be concise. 1.05. What is the ratio of the Trade (in US$) of Kyrgyz Republic in 2008 to that in 2009?
Offer a very short reply. 1.29. What is the ratio of the Trade (in US$) of Sweden in 2008 to that in 2009?
Your answer should be compact. 1.35. What is the ratio of the Trade (in US$) in Turkmenistan in 2008 to that in 2009?
Your response must be concise. 0.85. What is the ratio of the Trade (in US$) in Kosovo in 2008 to that in 2010?
Keep it short and to the point. 0.95. What is the ratio of the Trade (in US$) in Kyrgyz Republic in 2008 to that in 2010?
Offer a terse response. 1.21. What is the ratio of the Trade (in US$) in Sweden in 2008 to that in 2010?
Provide a short and direct response. 1.13. What is the ratio of the Trade (in US$) in Turkmenistan in 2008 to that in 2010?
Your answer should be compact. 0.77. What is the ratio of the Trade (in US$) of Kosovo in 2008 to that in 2011?
Offer a very short reply. 0.81. What is the ratio of the Trade (in US$) in Kyrgyz Republic in 2008 to that in 2011?
Give a very brief answer. 0.94. What is the ratio of the Trade (in US$) in Sweden in 2008 to that in 2011?
Your answer should be compact. 0.95. What is the ratio of the Trade (in US$) of Turkmenistan in 2008 to that in 2011?
Your answer should be compact. 0.61. What is the ratio of the Trade (in US$) in Kosovo in 2008 to that in 2012?
Offer a terse response. 0.91. What is the ratio of the Trade (in US$) of Kyrgyz Republic in 2008 to that in 2012?
Offer a terse response. 0.76. What is the ratio of the Trade (in US$) of Sweden in 2008 to that in 2012?
Offer a terse response. 0.99. What is the ratio of the Trade (in US$) of Turkmenistan in 2008 to that in 2012?
Make the answer very short. 0.5. What is the ratio of the Trade (in US$) in Kosovo in 2009 to that in 2010?
Provide a succinct answer. 0.91. What is the ratio of the Trade (in US$) in Kyrgyz Republic in 2009 to that in 2010?
Make the answer very short. 0.94. What is the ratio of the Trade (in US$) in Sweden in 2009 to that in 2010?
Offer a very short reply. 0.84. What is the ratio of the Trade (in US$) of Turkmenistan in 2009 to that in 2010?
Your answer should be compact. 0.91. What is the ratio of the Trade (in US$) of Kosovo in 2009 to that in 2011?
Offer a very short reply. 0.77. What is the ratio of the Trade (in US$) in Kyrgyz Republic in 2009 to that in 2011?
Ensure brevity in your answer.  0.73. What is the ratio of the Trade (in US$) of Sweden in 2009 to that in 2011?
Provide a short and direct response. 0.7. What is the ratio of the Trade (in US$) of Turkmenistan in 2009 to that in 2011?
Your response must be concise. 0.72. What is the ratio of the Trade (in US$) of Kosovo in 2009 to that in 2012?
Keep it short and to the point. 0.86. What is the ratio of the Trade (in US$) of Kyrgyz Republic in 2009 to that in 2012?
Offer a terse response. 0.59. What is the ratio of the Trade (in US$) in Sweden in 2009 to that in 2012?
Offer a very short reply. 0.74. What is the ratio of the Trade (in US$) of Turkmenistan in 2009 to that in 2012?
Ensure brevity in your answer.  0.59. What is the ratio of the Trade (in US$) of Kosovo in 2010 to that in 2011?
Offer a very short reply. 0.85. What is the ratio of the Trade (in US$) of Kyrgyz Republic in 2010 to that in 2011?
Make the answer very short. 0.77. What is the ratio of the Trade (in US$) in Sweden in 2010 to that in 2011?
Your answer should be compact. 0.84. What is the ratio of the Trade (in US$) in Turkmenistan in 2010 to that in 2011?
Offer a very short reply. 0.79. What is the ratio of the Trade (in US$) in Kosovo in 2010 to that in 2012?
Ensure brevity in your answer.  0.95. What is the ratio of the Trade (in US$) in Kyrgyz Republic in 2010 to that in 2012?
Give a very brief answer. 0.62. What is the ratio of the Trade (in US$) in Sweden in 2010 to that in 2012?
Make the answer very short. 0.88. What is the ratio of the Trade (in US$) of Turkmenistan in 2010 to that in 2012?
Your answer should be compact. 0.64. What is the ratio of the Trade (in US$) of Kosovo in 2011 to that in 2012?
Offer a very short reply. 1.12. What is the ratio of the Trade (in US$) in Kyrgyz Republic in 2011 to that in 2012?
Offer a very short reply. 0.8. What is the ratio of the Trade (in US$) in Turkmenistan in 2011 to that in 2012?
Provide a short and direct response. 0.82. What is the difference between the highest and the second highest Trade (in US$) in Kosovo?
Offer a very short reply. 3.94e+08. What is the difference between the highest and the second highest Trade (in US$) of Kyrgyz Republic?
Provide a short and direct response. 1.23e+09. What is the difference between the highest and the second highest Trade (in US$) of Sweden?
Offer a very short reply. 1.13e+1. What is the difference between the highest and the second highest Trade (in US$) in Turkmenistan?
Provide a short and direct response. 2.88e+09. What is the difference between the highest and the lowest Trade (in US$) of Kosovo?
Ensure brevity in your answer.  1.35e+09. What is the difference between the highest and the lowest Trade (in US$) of Kyrgyz Republic?
Your response must be concise. 3.09e+09. What is the difference between the highest and the lowest Trade (in US$) in Sweden?
Your response must be concise. 7.01e+1. What is the difference between the highest and the lowest Trade (in US$) of Turkmenistan?
Your answer should be very brief. 1.07e+1. 